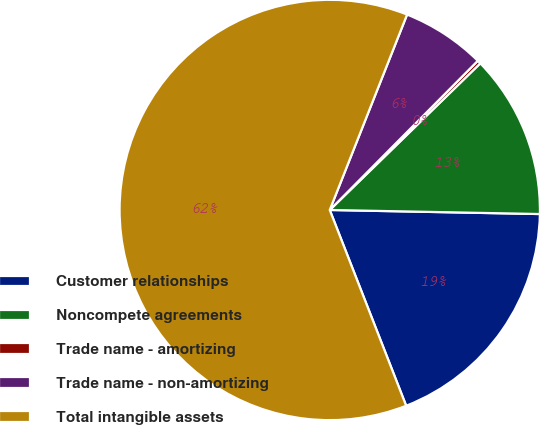Convert chart. <chart><loc_0><loc_0><loc_500><loc_500><pie_chart><fcel>Customer relationships<fcel>Noncompete agreements<fcel>Trade name - amortizing<fcel>Trade name - non-amortizing<fcel>Total intangible assets<nl><fcel>18.77%<fcel>12.6%<fcel>0.27%<fcel>6.44%<fcel>61.92%<nl></chart> 